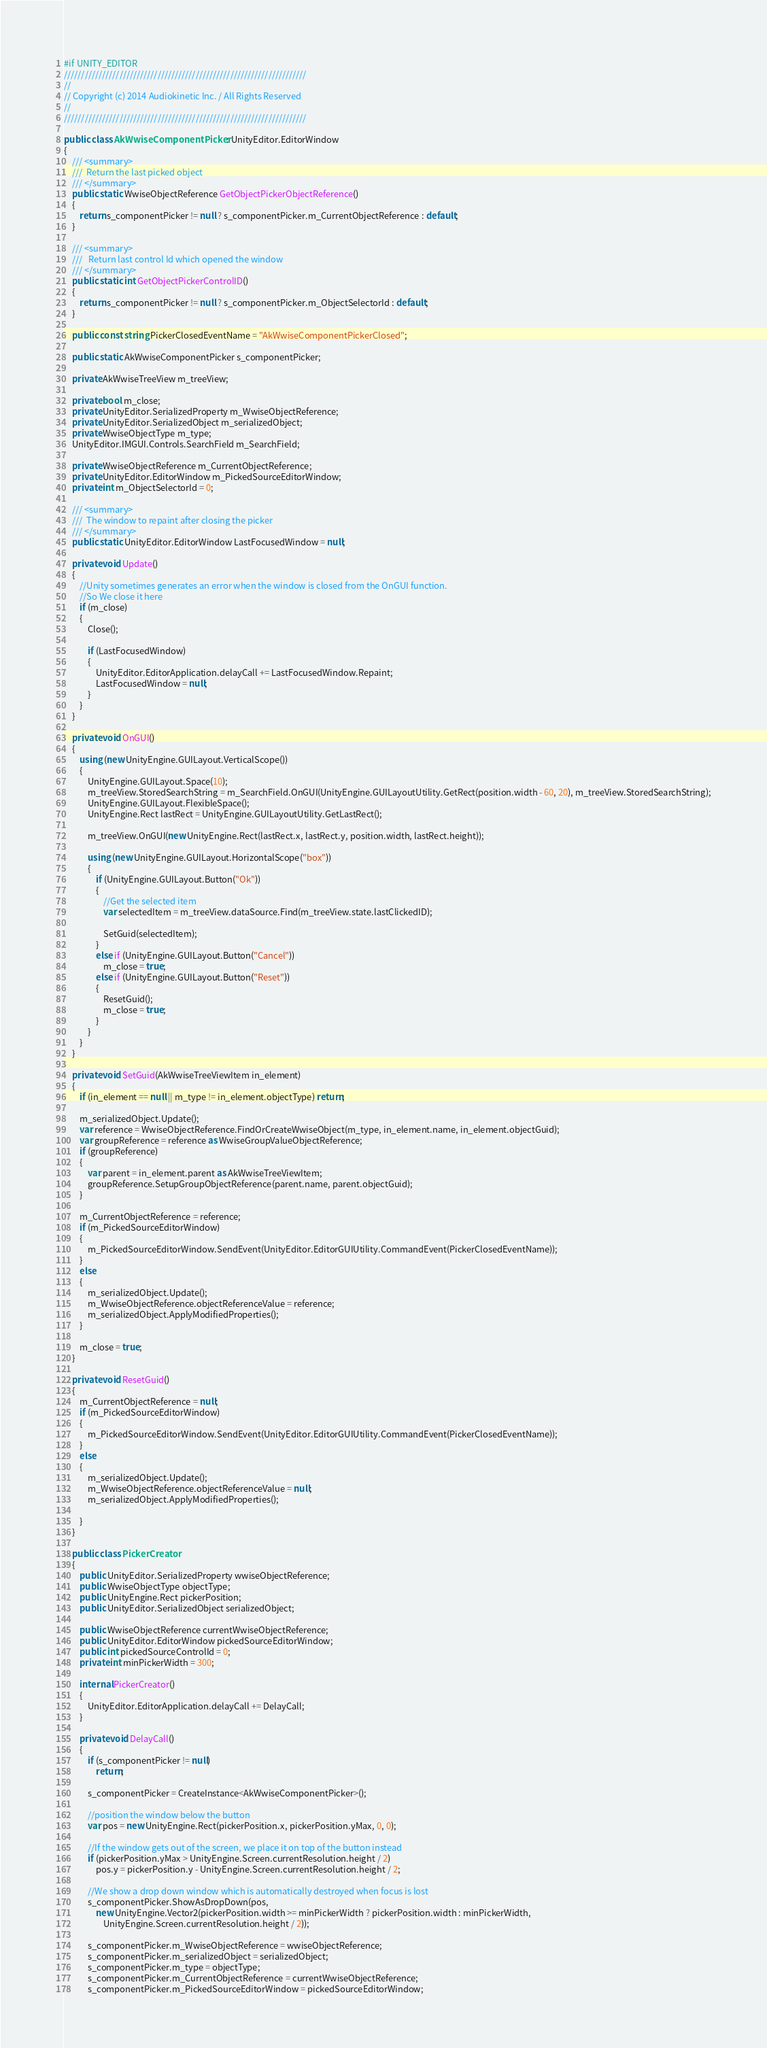Convert code to text. <code><loc_0><loc_0><loc_500><loc_500><_C#_>#if UNITY_EDITOR
//////////////////////////////////////////////////////////////////////
//
// Copyright (c) 2014 Audiokinetic Inc. / All Rights Reserved
//
//////////////////////////////////////////////////////////////////////

public class AkWwiseComponentPicker : UnityEditor.EditorWindow
{
	/// <summary>
	///  Return the last picked object
	/// </summary>
	public static WwiseObjectReference GetObjectPickerObjectReference()
	{
		return s_componentPicker != null ? s_componentPicker.m_CurrentObjectReference : default;
	}

	/// <summary>
	///   Return last control Id which opened the window
	/// </summary>
	public static int GetObjectPickerControlID()
	{
		return s_componentPicker != null ? s_componentPicker.m_ObjectSelectorId : default;
	}

	public const string PickerClosedEventName = "AkWwiseComponentPickerClosed";

	public static AkWwiseComponentPicker s_componentPicker;

	private AkWwiseTreeView m_treeView;

	private bool m_close;
	private UnityEditor.SerializedProperty m_WwiseObjectReference;
	private UnityEditor.SerializedObject m_serializedObject;
	private WwiseObjectType m_type;
	UnityEditor.IMGUI.Controls.SearchField m_SearchField;

	private WwiseObjectReference m_CurrentObjectReference;
	private UnityEditor.EditorWindow m_PickedSourceEditorWindow;
	private int m_ObjectSelectorId = 0;

	/// <summary>
	///  The window to repaint after closing the picker
	/// </summary>
	public static UnityEditor.EditorWindow LastFocusedWindow = null;

	private void Update()
	{
		//Unity sometimes generates an error when the window is closed from the OnGUI function.
		//So We close it here
		if (m_close)
		{
			Close();

			if (LastFocusedWindow)
			{
				UnityEditor.EditorApplication.delayCall += LastFocusedWindow.Repaint;
				LastFocusedWindow = null;
			}
		}
	}

	private void OnGUI()
	{
		using (new UnityEngine.GUILayout.VerticalScope())
		{
			UnityEngine.GUILayout.Space(10);
			m_treeView.StoredSearchString = m_SearchField.OnGUI(UnityEngine.GUILayoutUtility.GetRect(position.width - 60, 20), m_treeView.StoredSearchString);
			UnityEngine.GUILayout.FlexibleSpace();
			UnityEngine.Rect lastRect = UnityEngine.GUILayoutUtility.GetLastRect();

			m_treeView.OnGUI(new UnityEngine.Rect(lastRect.x, lastRect.y, position.width, lastRect.height));

			using (new UnityEngine.GUILayout.HorizontalScope("box"))
			{
				if (UnityEngine.GUILayout.Button("Ok"))
				{
					//Get the selected item
					var selectedItem = m_treeView.dataSource.Find(m_treeView.state.lastClickedID);

					SetGuid(selectedItem);
				}
				else if (UnityEngine.GUILayout.Button("Cancel"))
					m_close = true;
				else if (UnityEngine.GUILayout.Button("Reset"))
				{
					ResetGuid();
					m_close = true;
				}
			}
		}
	}

	private void SetGuid(AkWwiseTreeViewItem in_element)
	{
		if (in_element == null || m_type != in_element.objectType) return;

		m_serializedObject.Update();
		var reference = WwiseObjectReference.FindOrCreateWwiseObject(m_type, in_element.name, in_element.objectGuid);
		var groupReference = reference as WwiseGroupValueObjectReference;
		if (groupReference)
		{
			var parent = in_element.parent as AkWwiseTreeViewItem;
			groupReference.SetupGroupObjectReference(parent.name, parent.objectGuid);
		}

		m_CurrentObjectReference = reference;
		if (m_PickedSourceEditorWindow)
		{
			m_PickedSourceEditorWindow.SendEvent(UnityEditor.EditorGUIUtility.CommandEvent(PickerClosedEventName));
		}
		else
		{
			m_serializedObject.Update();
			m_WwiseObjectReference.objectReferenceValue = reference;
			m_serializedObject.ApplyModifiedProperties();
		}

		m_close = true;
	}

	private void ResetGuid()
	{
		m_CurrentObjectReference = null;
		if (m_PickedSourceEditorWindow)
		{
			m_PickedSourceEditorWindow.SendEvent(UnityEditor.EditorGUIUtility.CommandEvent(PickerClosedEventName));
		}
		else
		{
			m_serializedObject.Update();
			m_WwiseObjectReference.objectReferenceValue = null;
			m_serializedObject.ApplyModifiedProperties();

		}
	}

	public class PickerCreator
	{
		public UnityEditor.SerializedProperty wwiseObjectReference;
		public WwiseObjectType objectType;
		public UnityEngine.Rect pickerPosition;
		public UnityEditor.SerializedObject serializedObject;

		public WwiseObjectReference currentWwiseObjectReference;
		public UnityEditor.EditorWindow pickedSourceEditorWindow;
		public int pickedSourceControlId = 0;
		private int minPickerWidth = 300;

		internal PickerCreator()
		{
			UnityEditor.EditorApplication.delayCall += DelayCall;
		}

		private void DelayCall()
		{
			if (s_componentPicker != null)
				return;

			s_componentPicker = CreateInstance<AkWwiseComponentPicker>();

			//position the window below the button
			var pos = new UnityEngine.Rect(pickerPosition.x, pickerPosition.yMax, 0, 0);

			//If the window gets out of the screen, we place it on top of the button instead
			if (pickerPosition.yMax > UnityEngine.Screen.currentResolution.height / 2)
				pos.y = pickerPosition.y - UnityEngine.Screen.currentResolution.height / 2;

			//We show a drop down window which is automatically destroyed when focus is lost
			s_componentPicker.ShowAsDropDown(pos,
				new UnityEngine.Vector2(pickerPosition.width >= minPickerWidth ? pickerPosition.width : minPickerWidth,
					UnityEngine.Screen.currentResolution.height / 2));

			s_componentPicker.m_WwiseObjectReference = wwiseObjectReference;
			s_componentPicker.m_serializedObject = serializedObject;
			s_componentPicker.m_type = objectType;
			s_componentPicker.m_CurrentObjectReference = currentWwiseObjectReference;
			s_componentPicker.m_PickedSourceEditorWindow = pickedSourceEditorWindow;</code> 